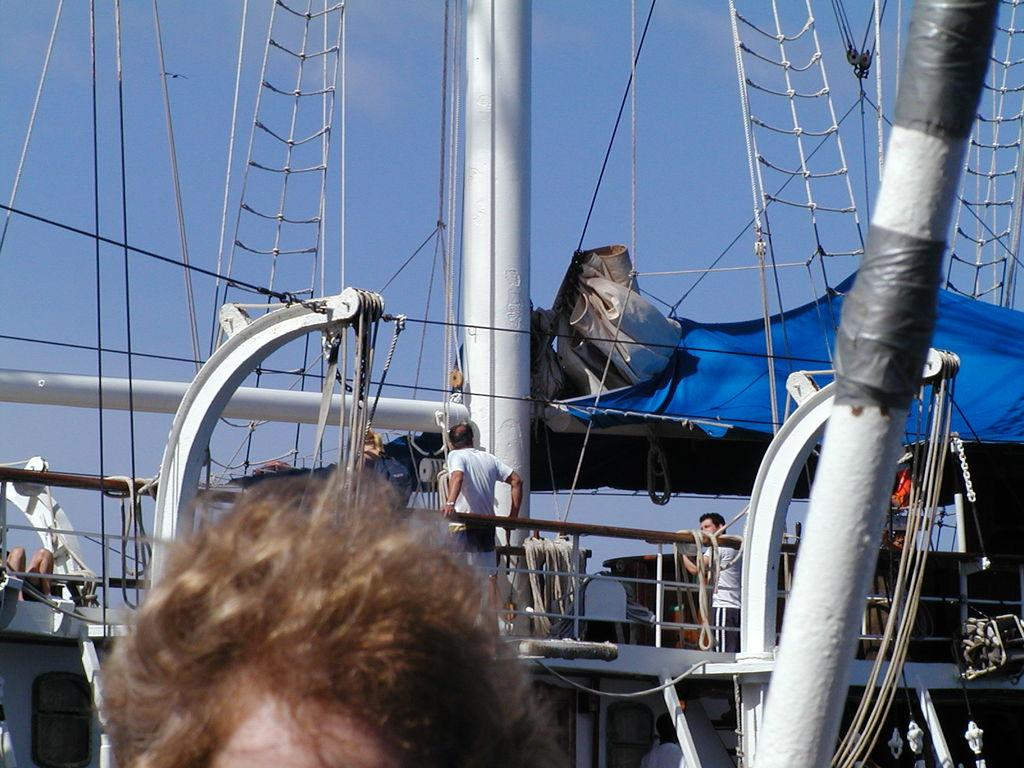What is the main subject of the image? There is a person standing in the image. What can be seen in the background of the image? There is a ship in the background of the image. Are there any other people visible in the image? Yes, there are people standing on the ship. What is visible in the sky in the image? The sky is visible in the image. What type of story is being told by the dirt in the image? There is no dirt present in the image, so no story can be told by it. 